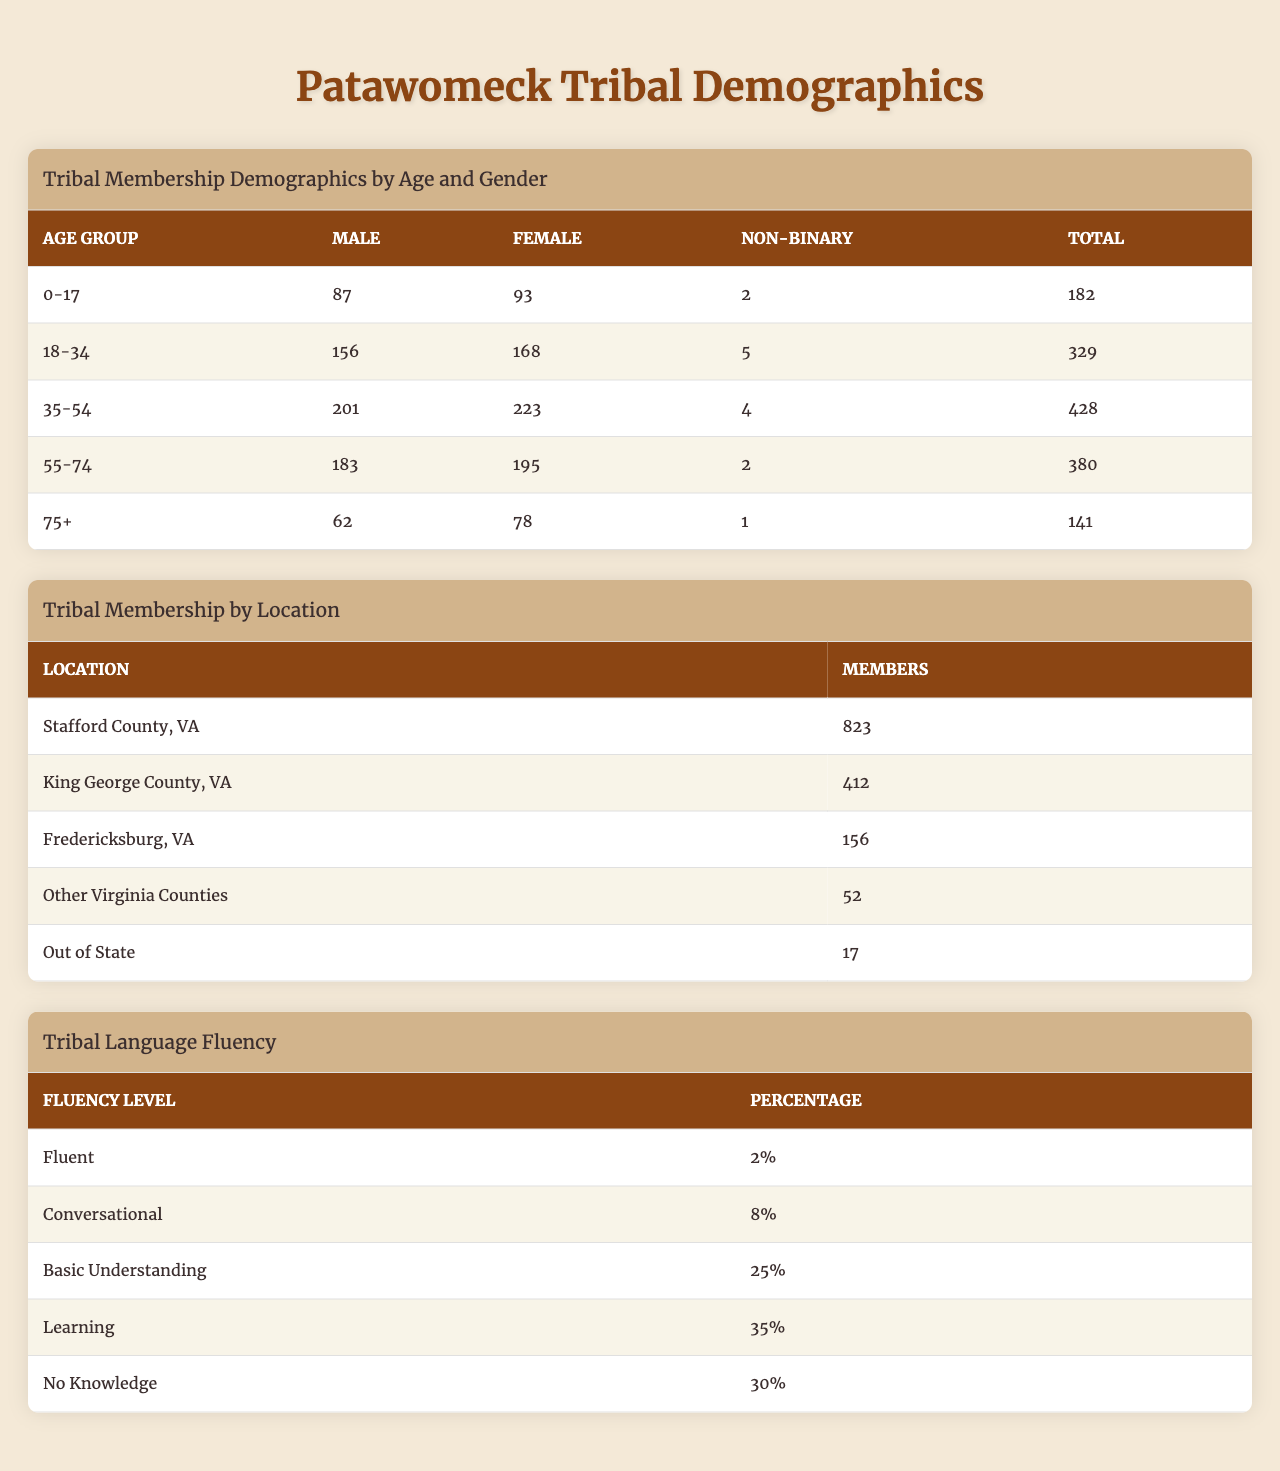What is the total number of male members in the Patawomeck tribe aged 35-54? Referring to the table for the age group "35-54," the number of male members is listed as 201.
Answer: 201 What is the total membership of the Patawomeck tribe aged 75 and older? The age group "75+" shows a total of 141 members according to the table.
Answer: 141 Which age group has the highest number of female members? Comparing the female counts across all age groups, "35-54" has the highest number with 223 female members.
Answer: 35-54 How many non-binary members are there in the tribe? The total non-binary members can be calculated by summing the non-binary numbers: 2 (0-17) + 5 (18-34) + 4 (35-54) + 2 (55-74) + 1 (75+) = 14.
Answer: 14 Which age group has the largest total membership? The age groups' total memberships are as follows: 182 (0-17), 329 (18-34), 428 (35-54), 380 (55-74), and 141 (75+). The highest is 428 in the "35-54" age group.
Answer: 35-54 What is the percentage of members who are fluent in the tribal language? The table indicates that 2% of members are fluent in the tribal language.
Answer: 2% Is there a higher number of females or males in the age group 55-74? In the "55-74" age group, there are 195 females and 183 males. Since 195 > 183, there are more females.
Answer: Yes How many members live in Stafford County, VA? The table shows that 823 members reside in Stafford County, VA.
Answer: 823 What is the average number of members in the age group 0-17 and 75+? The total for the age group "0-17" is 182 and for "75+" is 141. Adding these gives 323, and dividing by 2 yields an average of 161.5.
Answer: 161.5 What is the lowest membership count by location? The lowest membership count in the "Tribal Membership by Location" table is for "Out of State," with 17 members.
Answer: 17 